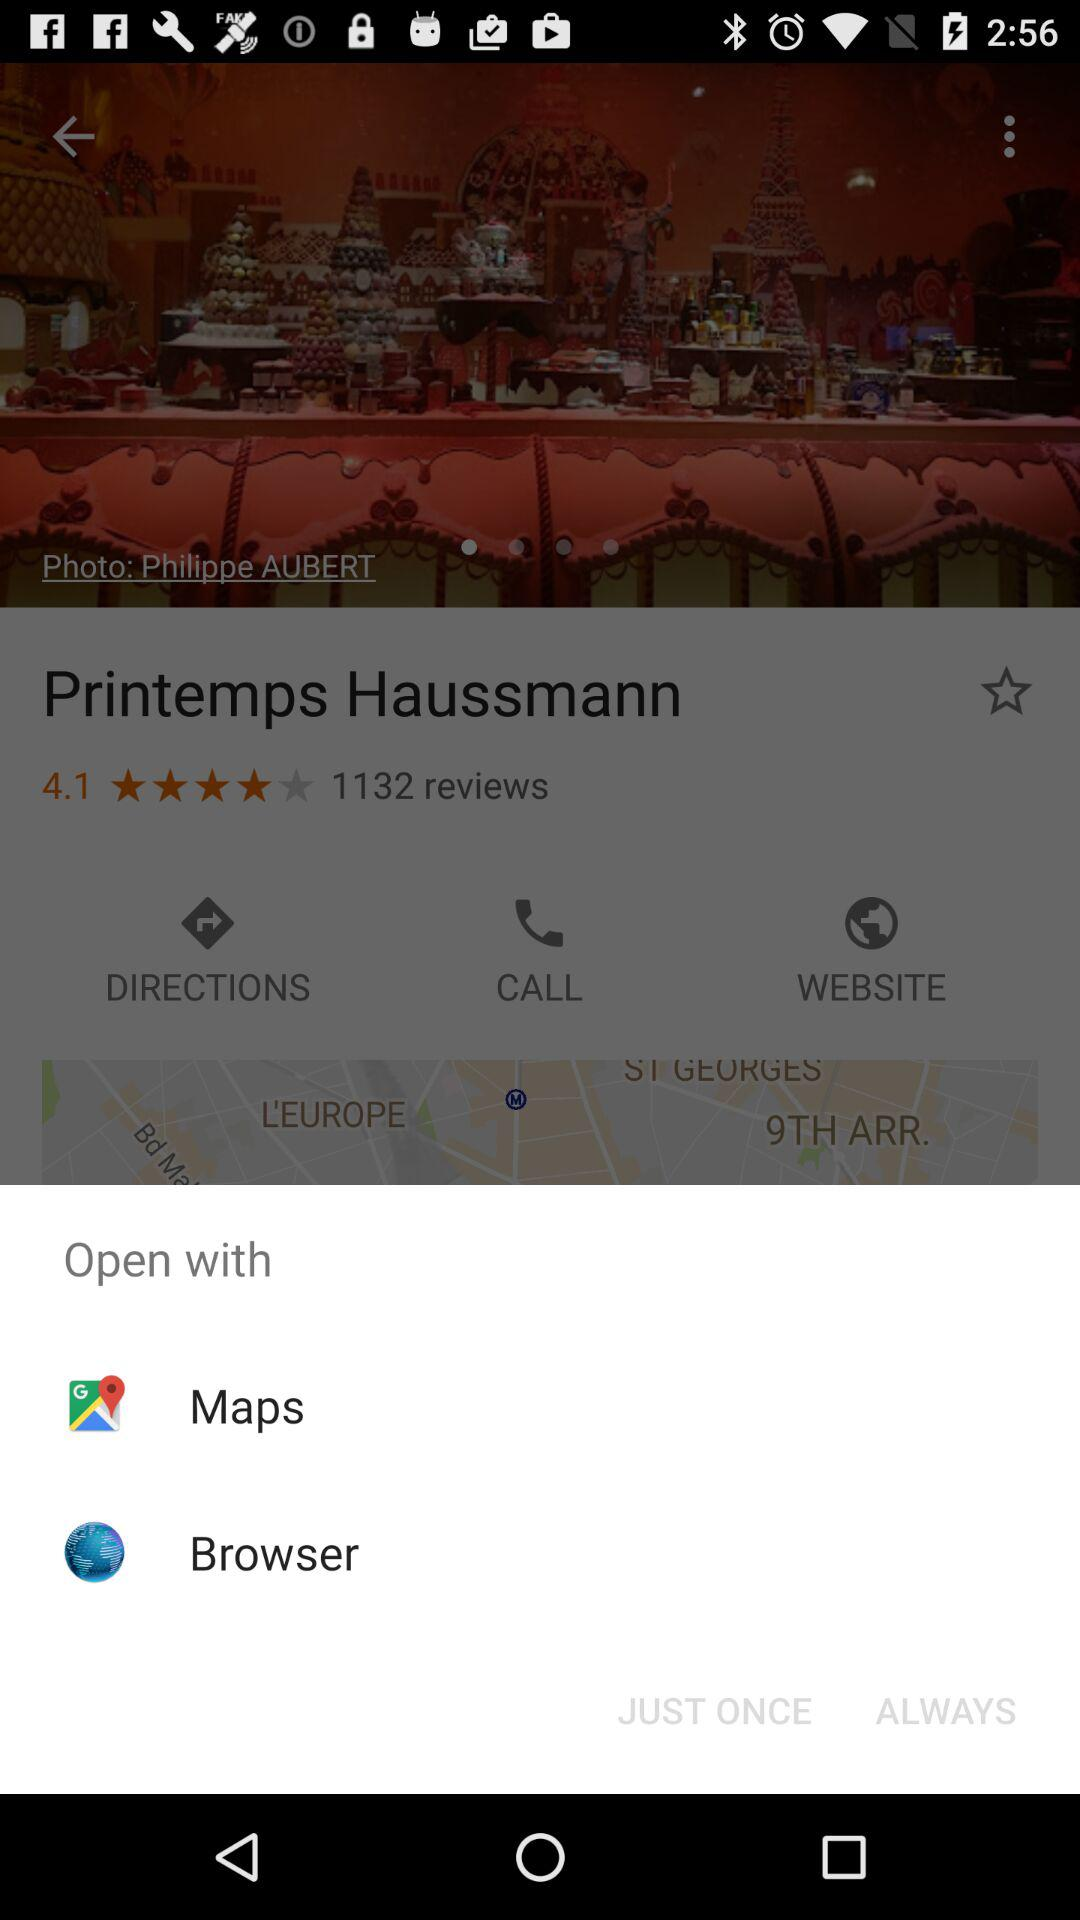Which options are available for opening the location? The options "Maps" and "Browser" are available for opening the location. 